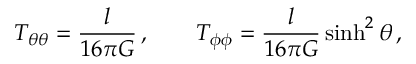Convert formula to latex. <formula><loc_0><loc_0><loc_500><loc_500>T _ { \theta \theta } = \frac { l } { 1 6 \pi G } \, , \quad T _ { \phi \phi } = \frac { l } { 1 6 \pi G } \sinh ^ { 2 } \theta \, ,</formula> 